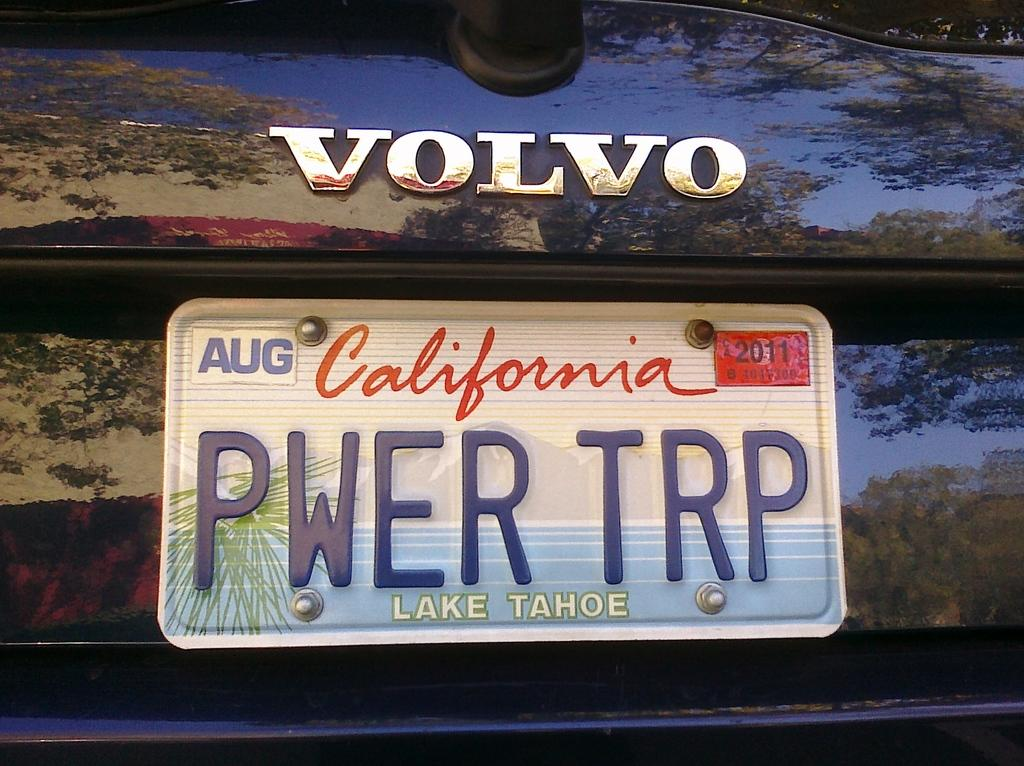<image>
Summarize the visual content of the image. White California license plate which says PWERTRP on it. 